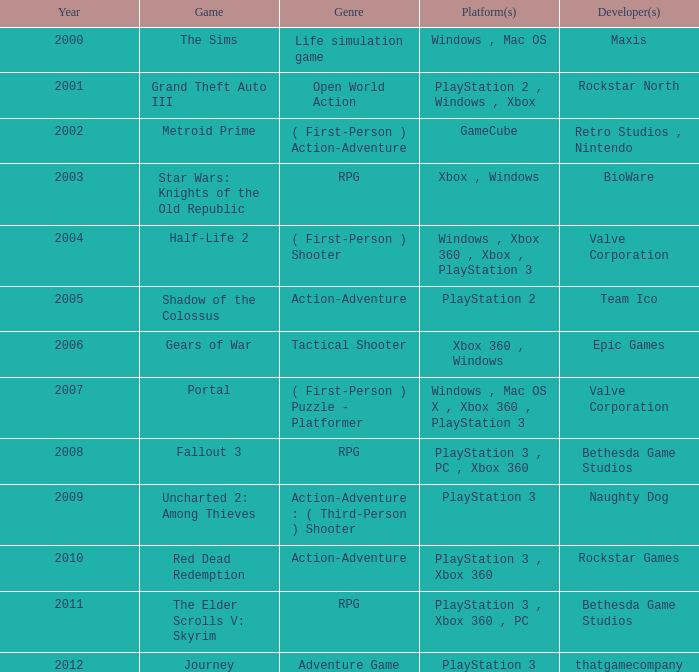Write the full table. {'header': ['Year', 'Game', 'Genre', 'Platform(s)', 'Developer(s)'], 'rows': [['2000', 'The Sims', 'Life simulation game', 'Windows , Mac OS', 'Maxis'], ['2001', 'Grand Theft Auto III', 'Open World Action', 'PlayStation 2 , Windows , Xbox', 'Rockstar North'], ['2002', 'Metroid Prime', '( First-Person ) Action-Adventure', 'GameCube', 'Retro Studios , Nintendo'], ['2003', 'Star Wars: Knights of the Old Republic', 'RPG', 'Xbox , Windows', 'BioWare'], ['2004', 'Half-Life 2', '( First-Person ) Shooter', 'Windows , Xbox 360 , Xbox , PlayStation 3', 'Valve Corporation'], ['2005', 'Shadow of the Colossus', 'Action-Adventure', 'PlayStation 2', 'Team Ico'], ['2006', 'Gears of War', 'Tactical Shooter', 'Xbox 360 , Windows', 'Epic Games'], ['2007', 'Portal', '( First-Person ) Puzzle - Platformer', 'Windows , Mac OS X , Xbox 360 , PlayStation 3', 'Valve Corporation'], ['2008', 'Fallout 3', 'RPG', 'PlayStation 3 , PC , Xbox 360', 'Bethesda Game Studios'], ['2009', 'Uncharted 2: Among Thieves', 'Action-Adventure : ( Third-Person ) Shooter', 'PlayStation 3', 'Naughty Dog'], ['2010', 'Red Dead Redemption', 'Action-Adventure', 'PlayStation 3 , Xbox 360', 'Rockstar Games'], ['2011', 'The Elder Scrolls V: Skyrim', 'RPG', 'PlayStation 3 , Xbox 360 , PC', 'Bethesda Game Studios'], ['2012', 'Journey', 'Adventure Game', 'PlayStation 3', 'thatgamecompany']]} What was the game that came out in 2005? Shadow of the Colossus. 